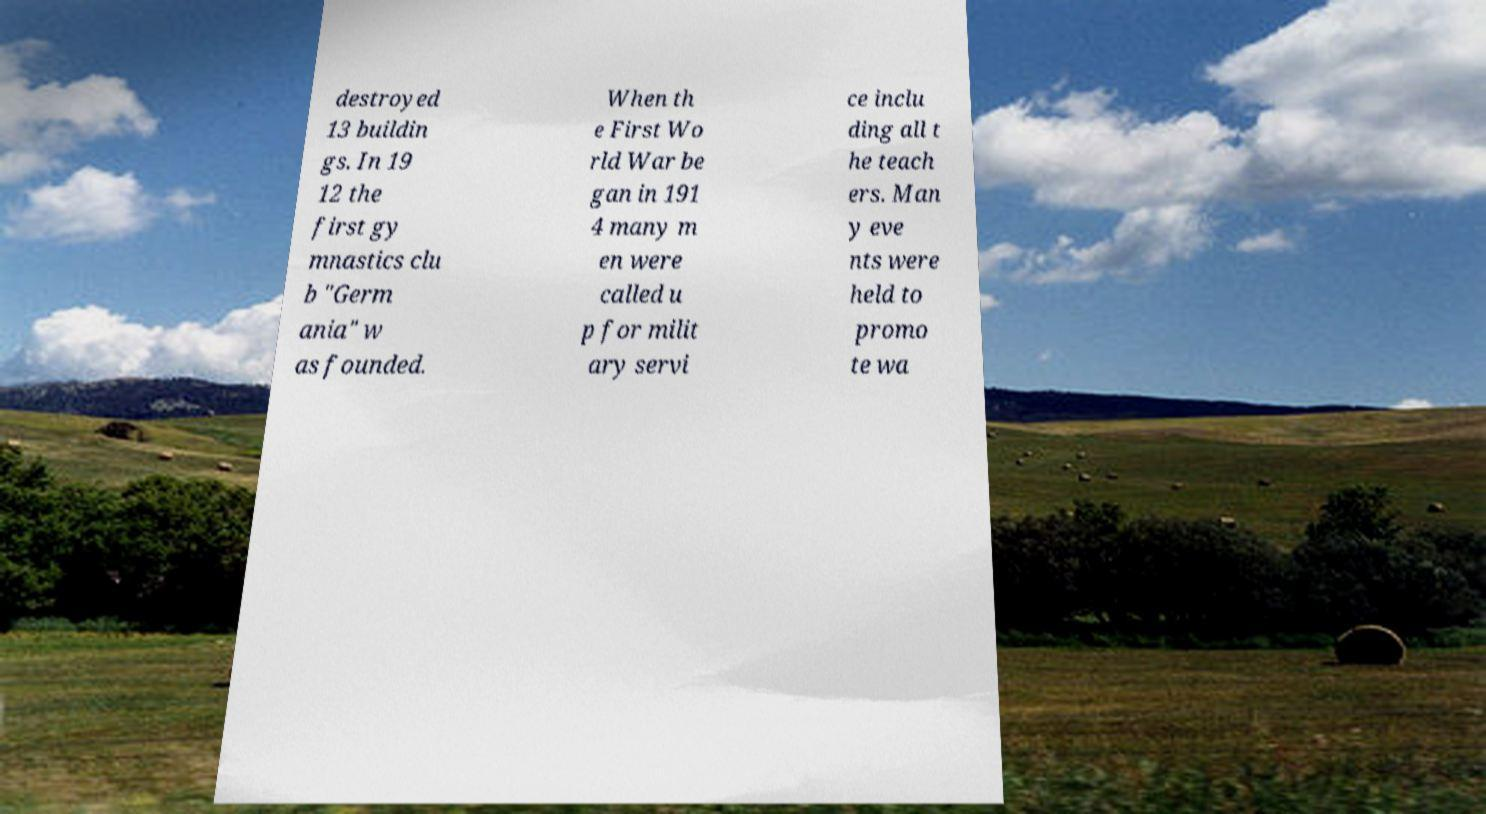Can you read and provide the text displayed in the image?This photo seems to have some interesting text. Can you extract and type it out for me? destroyed 13 buildin gs. In 19 12 the first gy mnastics clu b "Germ ania" w as founded. When th e First Wo rld War be gan in 191 4 many m en were called u p for milit ary servi ce inclu ding all t he teach ers. Man y eve nts were held to promo te wa 